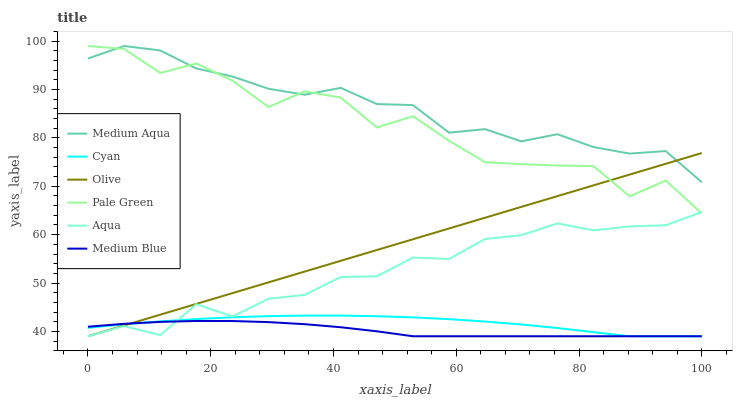Does Medium Blue have the minimum area under the curve?
Answer yes or no. Yes. Does Medium Aqua have the maximum area under the curve?
Answer yes or no. Yes. Does Aqua have the minimum area under the curve?
Answer yes or no. No. Does Aqua have the maximum area under the curve?
Answer yes or no. No. Is Olive the smoothest?
Answer yes or no. Yes. Is Pale Green the roughest?
Answer yes or no. Yes. Is Aqua the smoothest?
Answer yes or no. No. Is Aqua the roughest?
Answer yes or no. No. Does Medium Blue have the lowest value?
Answer yes or no. Yes. Does Pale Green have the lowest value?
Answer yes or no. No. Does Medium Aqua have the highest value?
Answer yes or no. Yes. Does Aqua have the highest value?
Answer yes or no. No. Is Medium Blue less than Pale Green?
Answer yes or no. Yes. Is Pale Green greater than Medium Blue?
Answer yes or no. Yes. Does Medium Blue intersect Aqua?
Answer yes or no. Yes. Is Medium Blue less than Aqua?
Answer yes or no. No. Is Medium Blue greater than Aqua?
Answer yes or no. No. Does Medium Blue intersect Pale Green?
Answer yes or no. No. 